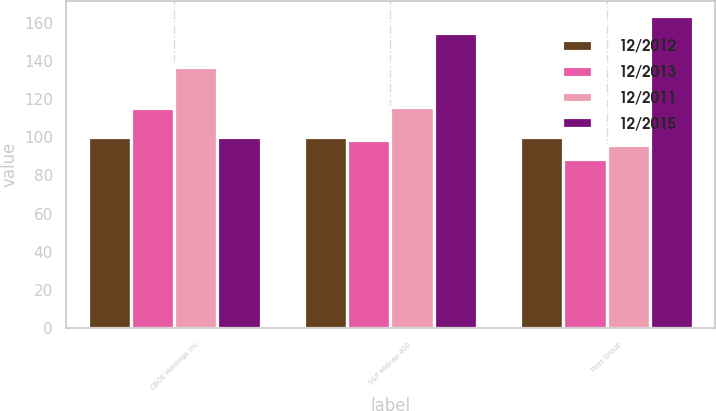Convert chart to OTSL. <chart><loc_0><loc_0><loc_500><loc_500><stacked_bar_chart><ecel><fcel>CBOE Holdings Inc<fcel>S&P Midcap 400<fcel>Peer Group<nl><fcel>12/2012<fcel>100<fcel>100<fcel>100<nl><fcel>12/2013<fcel>115.04<fcel>98.27<fcel>88.52<nl><fcel>12/2011<fcel>137.01<fcel>115.84<fcel>96.01<nl><fcel>12/2015<fcel>100<fcel>154.64<fcel>163.29<nl></chart> 